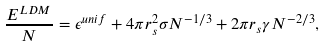Convert formula to latex. <formula><loc_0><loc_0><loc_500><loc_500>\frac { E ^ { L D M } } { N } = \epsilon ^ { u n i f } + 4 \pi r _ { s } ^ { 2 } \sigma N ^ { - 1 / 3 } + 2 \pi r _ { s } \gamma N ^ { - 2 / 3 } ,</formula> 